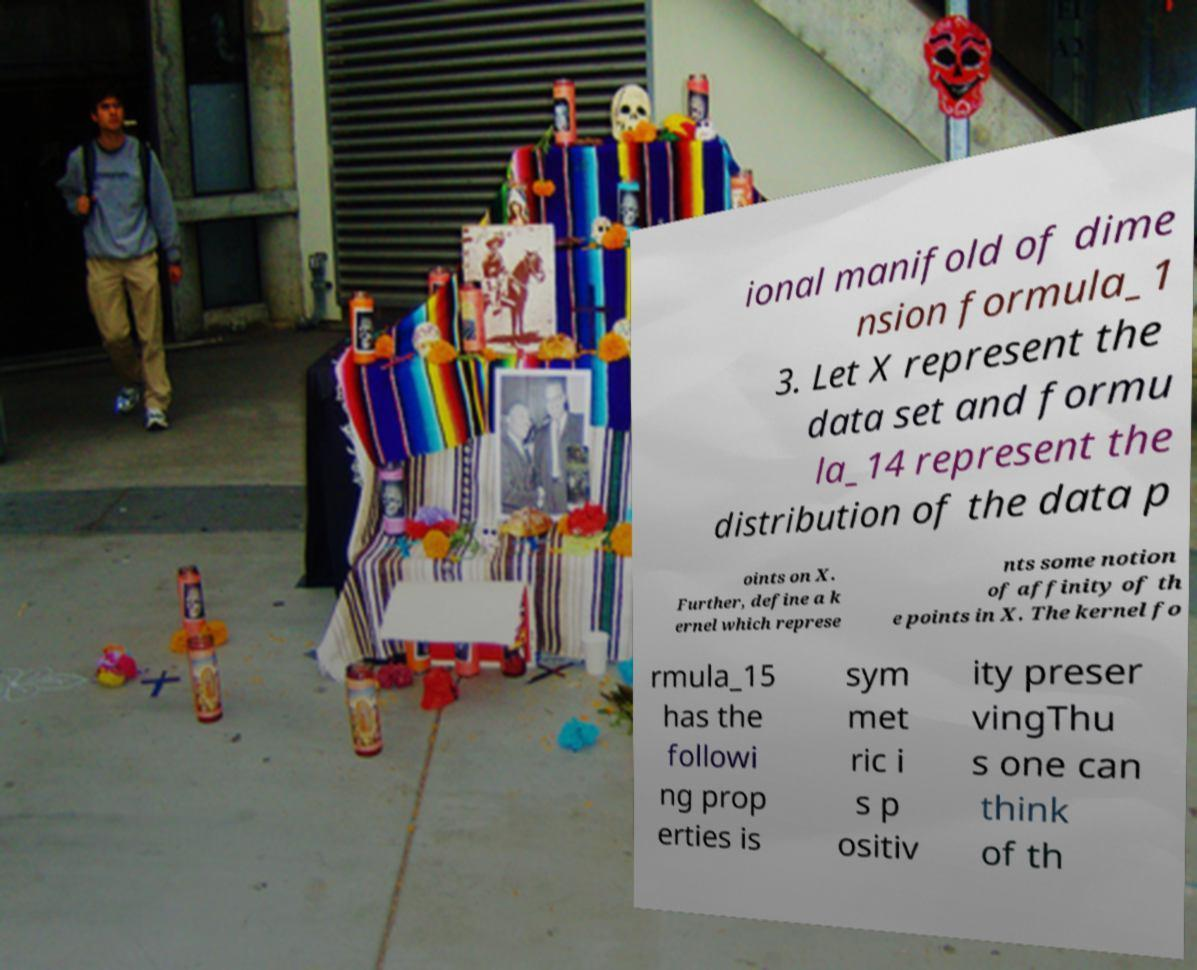What messages or text are displayed in this image? I need them in a readable, typed format. ional manifold of dime nsion formula_1 3. Let X represent the data set and formu la_14 represent the distribution of the data p oints on X. Further, define a k ernel which represe nts some notion of affinity of th e points in X. The kernel fo rmula_15 has the followi ng prop erties is sym met ric i s p ositiv ity preser vingThu s one can think of th 